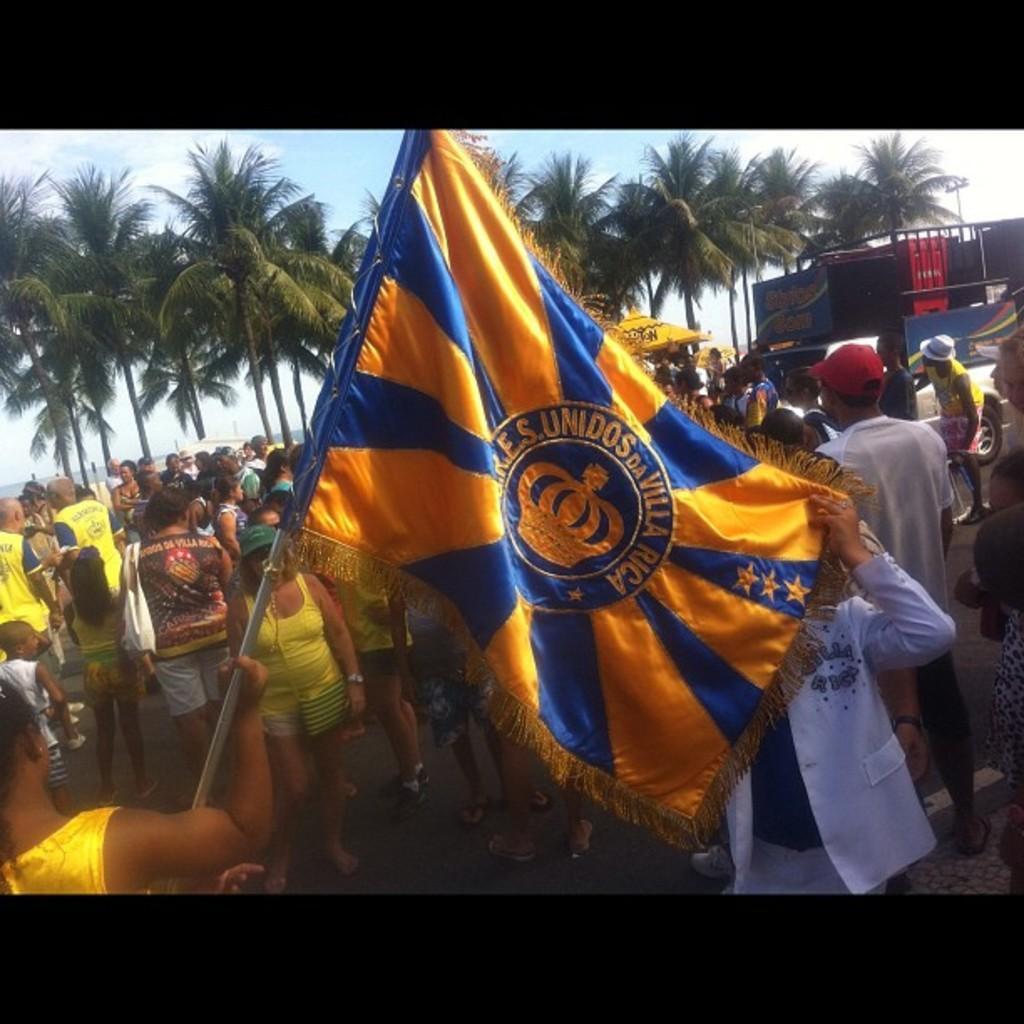Please provide a concise description of this image. In this image I can see number of persons are standing on the ground and a person is holding a flag which is blue and orange in color. In the background I can see few trees which are green in color, a orange colored tent, a vehicle and the sky. 